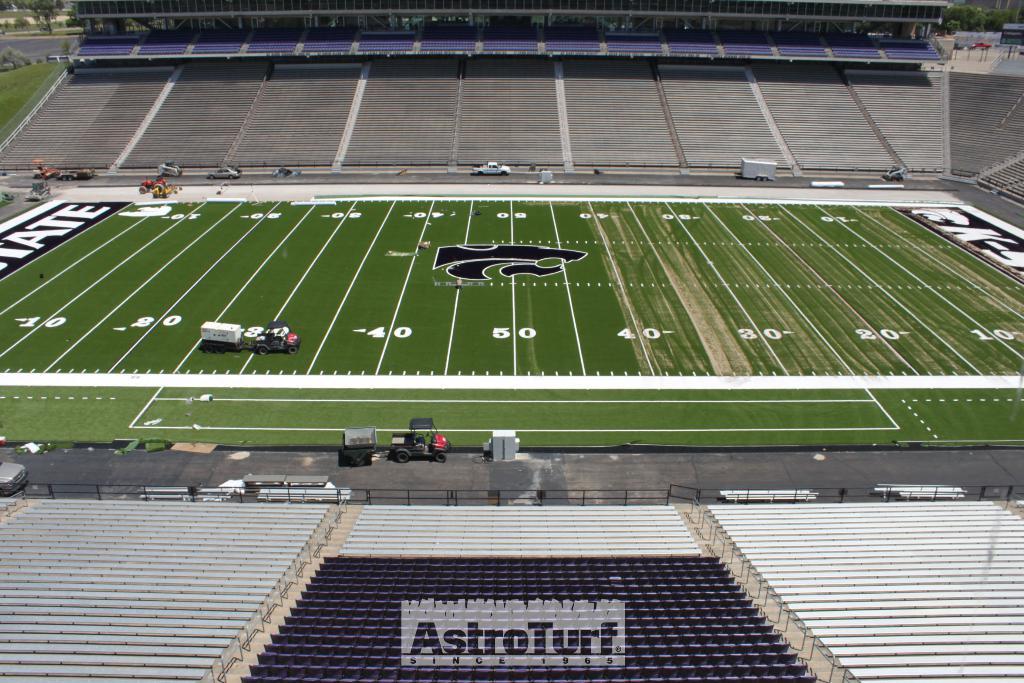What name can be read on the seats?
Provide a short and direct response. Astroturf. Is there a 40 yard line?
Offer a terse response. Yes. 